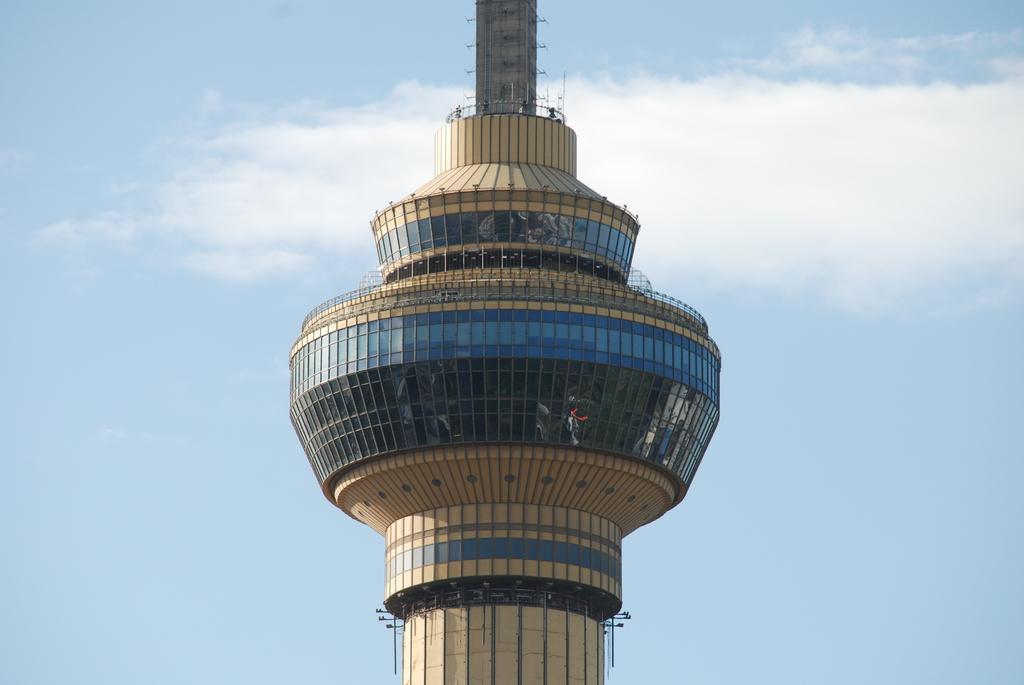Could you give a brief overview of what you see in this image? In this picture there is a concrete tower. Here we can see lights, glass, fencing and poles. In the back we can see sky and clouds. 